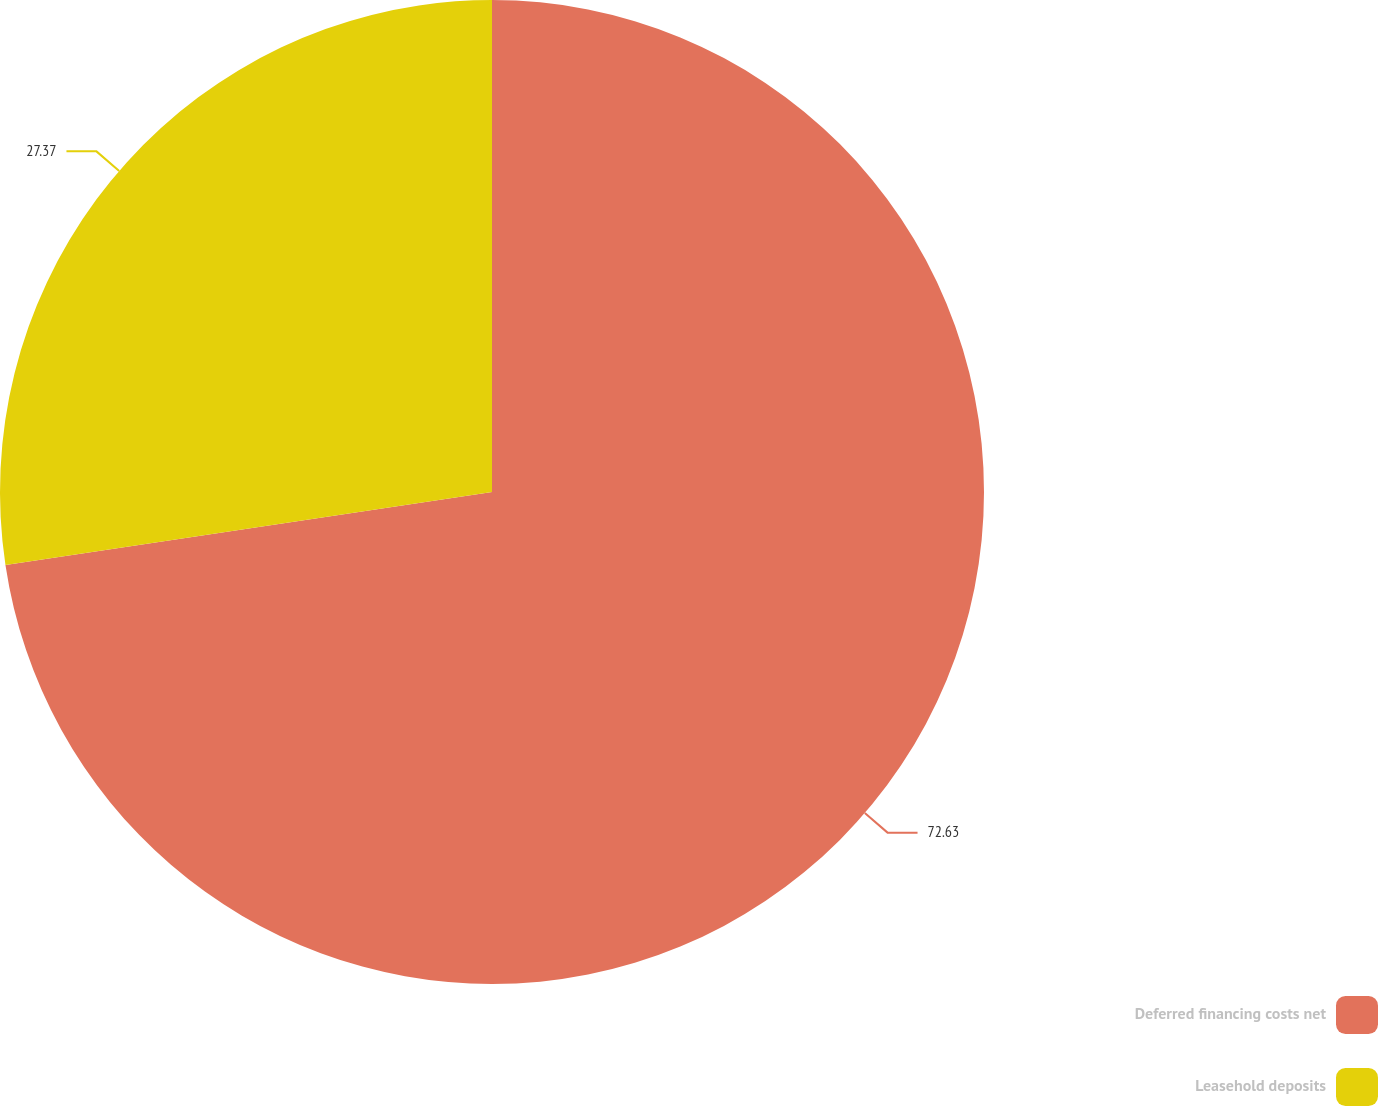Convert chart to OTSL. <chart><loc_0><loc_0><loc_500><loc_500><pie_chart><fcel>Deferred financing costs net<fcel>Leasehold deposits<nl><fcel>72.63%<fcel>27.37%<nl></chart> 